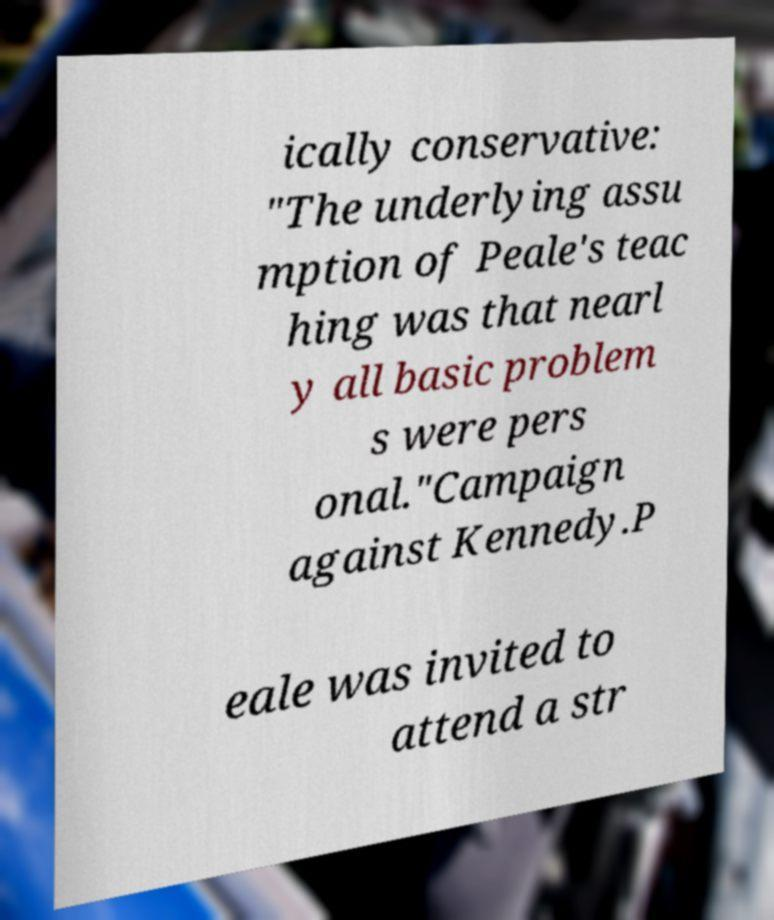Can you accurately transcribe the text from the provided image for me? ically conservative: "The underlying assu mption of Peale's teac hing was that nearl y all basic problem s were pers onal."Campaign against Kennedy.P eale was invited to attend a str 